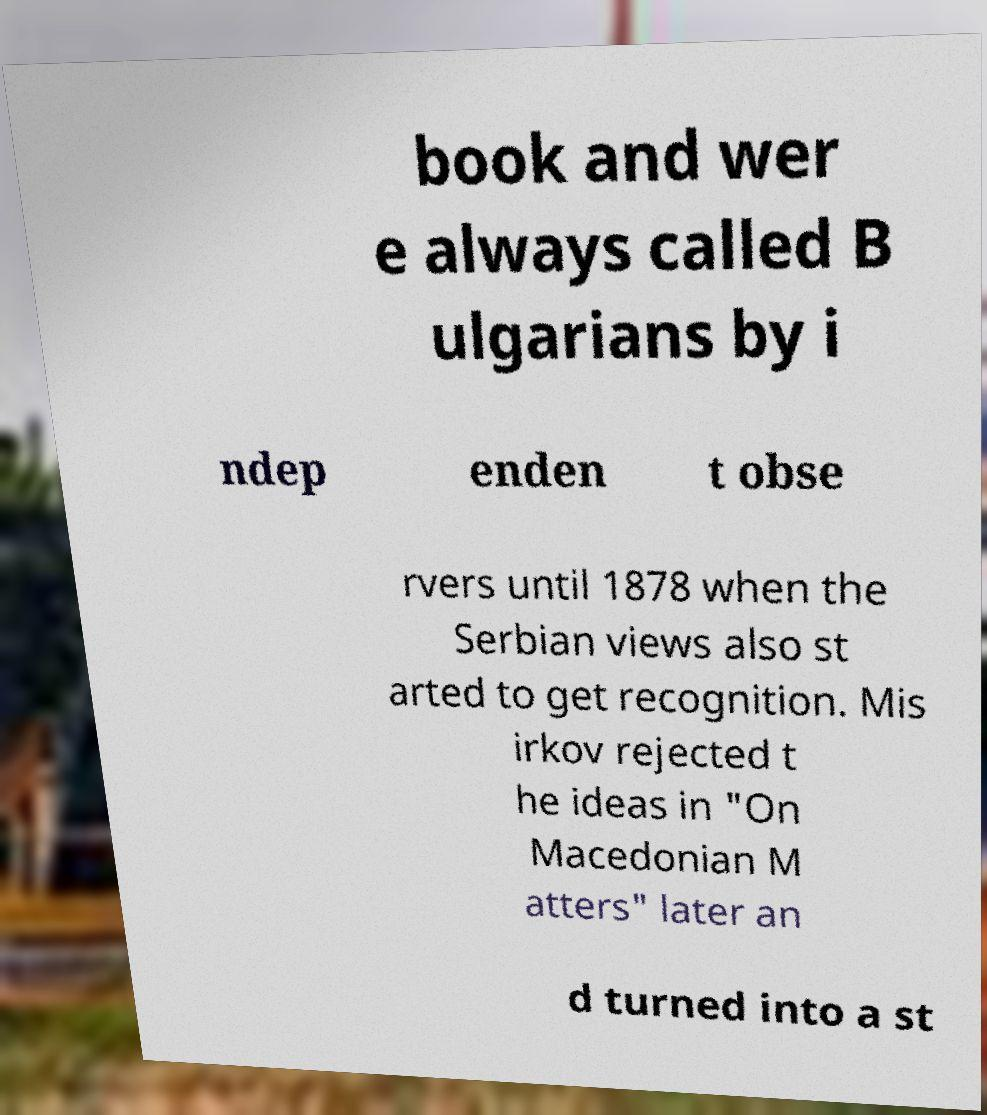Could you extract and type out the text from this image? book and wer e always called B ulgarians by i ndep enden t obse rvers until 1878 when the Serbian views also st arted to get recognition. Mis irkov rejected t he ideas in "On Macedonian M atters" later an d turned into a st 